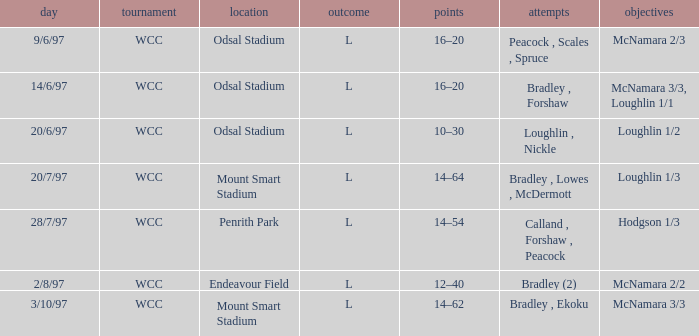What was the score on 20/6/97? 10–30. 